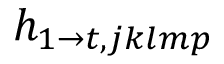Convert formula to latex. <formula><loc_0><loc_0><loc_500><loc_500>h _ { 1 \rightarrow t , j k l m p }</formula> 